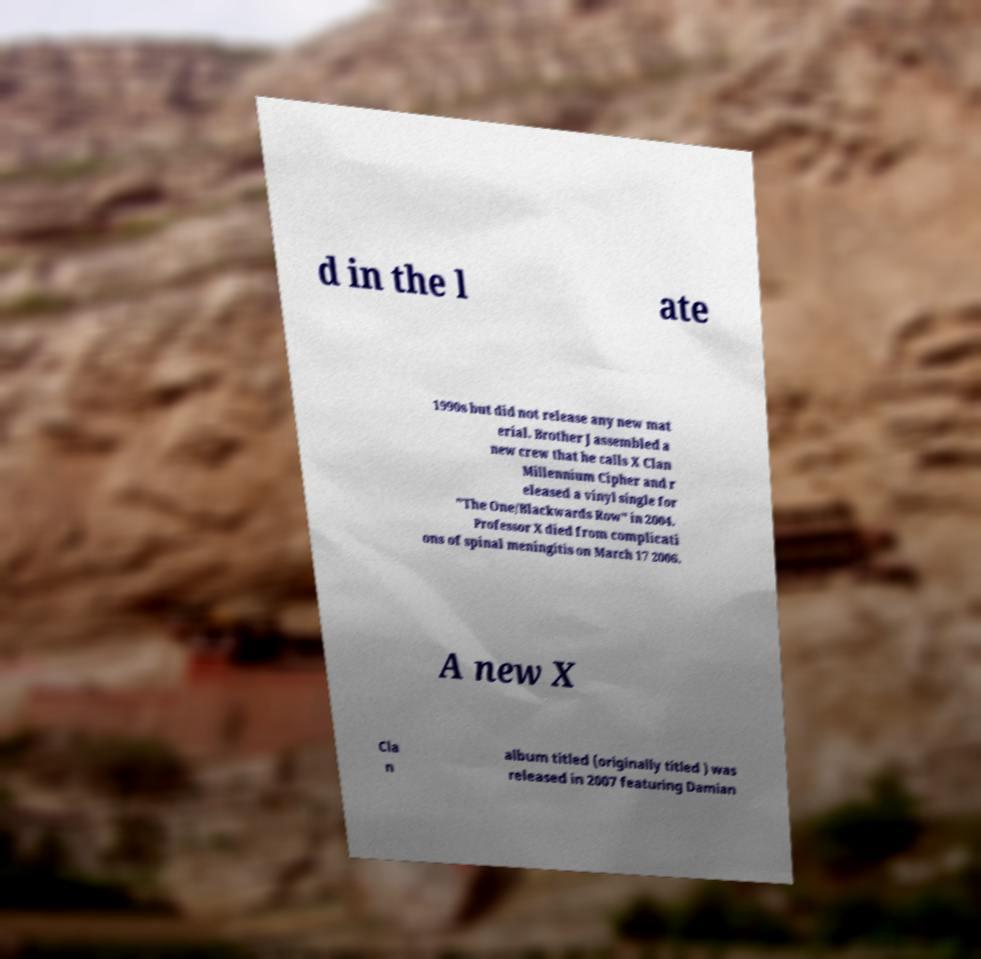Could you assist in decoding the text presented in this image and type it out clearly? d in the l ate 1990s but did not release any new mat erial. Brother J assembled a new crew that he calls X Clan Millennium Cipher and r eleased a vinyl single for "The One/Blackwards Row" in 2004. Professor X died from complicati ons of spinal meningitis on March 17 2006. A new X Cla n album titled (originally titled ) was released in 2007 featuring Damian 